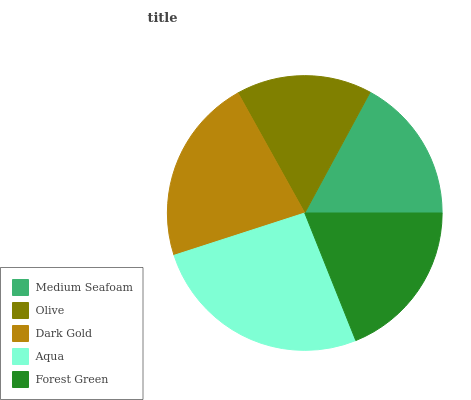Is Olive the minimum?
Answer yes or no. Yes. Is Aqua the maximum?
Answer yes or no. Yes. Is Dark Gold the minimum?
Answer yes or no. No. Is Dark Gold the maximum?
Answer yes or no. No. Is Dark Gold greater than Olive?
Answer yes or no. Yes. Is Olive less than Dark Gold?
Answer yes or no. Yes. Is Olive greater than Dark Gold?
Answer yes or no. No. Is Dark Gold less than Olive?
Answer yes or no. No. Is Forest Green the high median?
Answer yes or no. Yes. Is Forest Green the low median?
Answer yes or no. Yes. Is Olive the high median?
Answer yes or no. No. Is Medium Seafoam the low median?
Answer yes or no. No. 